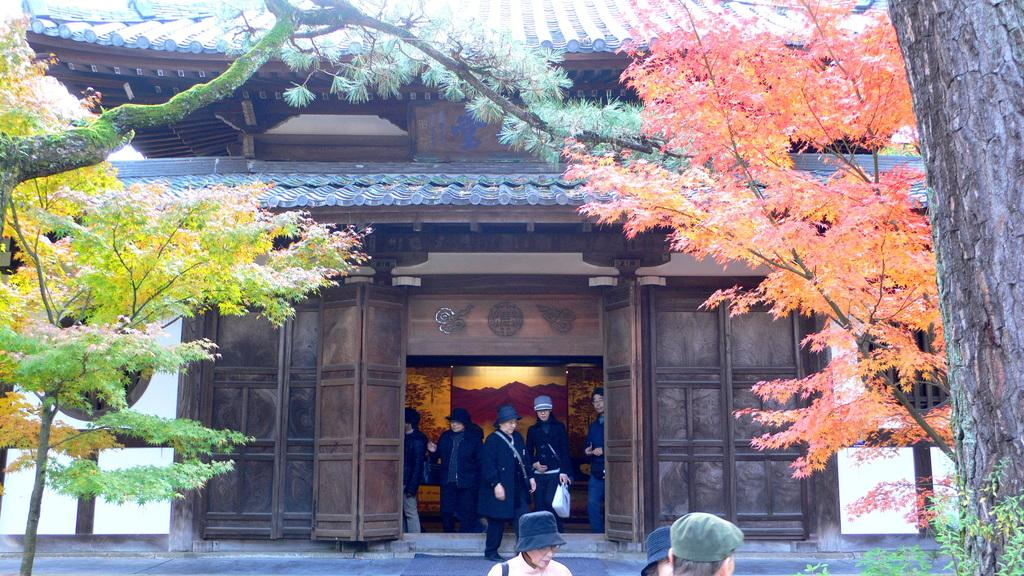What is happening in the image? There are people standing in the image. What can be seen in the background behind the people? There are trees in front of the people. What type of structure is suggested by the wooden wall in the image? The wooden wall suggests the presence of a house. What type of appliance can be seen on the roof of the house in the image? There is no appliance visible on the roof of the house in the image. Can you tell me how many giraffes are present in the image? There are no giraffes present in the image. 